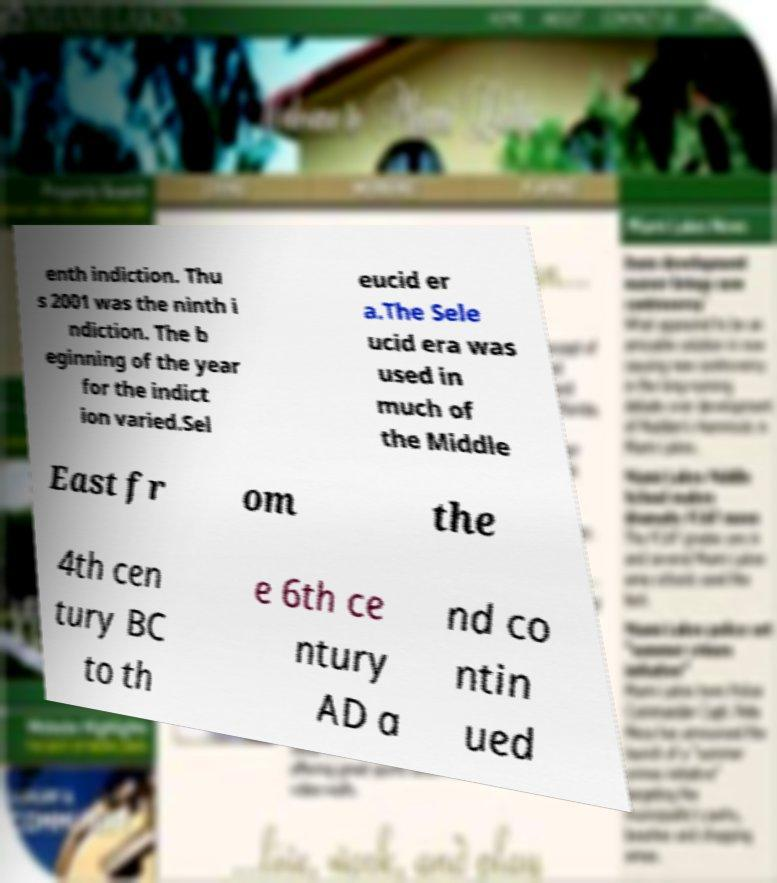There's text embedded in this image that I need extracted. Can you transcribe it verbatim? enth indiction. Thu s 2001 was the ninth i ndiction. The b eginning of the year for the indict ion varied.Sel eucid er a.The Sele ucid era was used in much of the Middle East fr om the 4th cen tury BC to th e 6th ce ntury AD a nd co ntin ued 